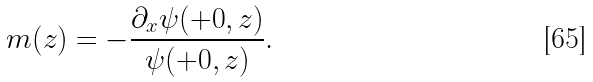<formula> <loc_0><loc_0><loc_500><loc_500>m ( z ) = - \frac { \partial _ { x } \psi ( + 0 , z ) } { \psi ( + 0 , z ) } .</formula> 